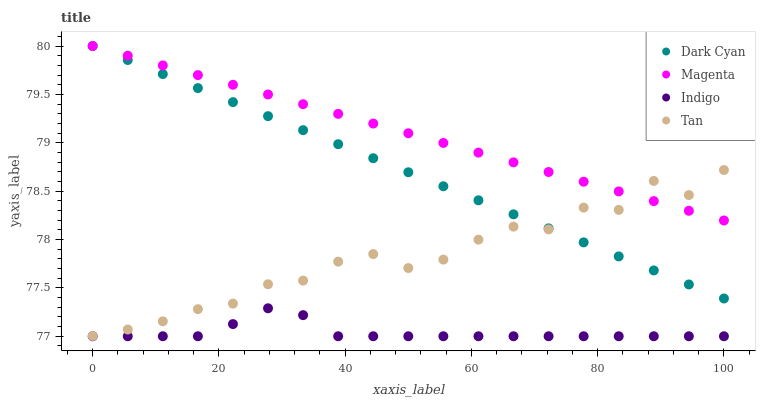Does Indigo have the minimum area under the curve?
Answer yes or no. Yes. Does Magenta have the maximum area under the curve?
Answer yes or no. Yes. Does Magenta have the minimum area under the curve?
Answer yes or no. No. Does Indigo have the maximum area under the curve?
Answer yes or no. No. Is Dark Cyan the smoothest?
Answer yes or no. Yes. Is Tan the roughest?
Answer yes or no. Yes. Is Magenta the smoothest?
Answer yes or no. No. Is Magenta the roughest?
Answer yes or no. No. Does Indigo have the lowest value?
Answer yes or no. Yes. Does Magenta have the lowest value?
Answer yes or no. No. Does Magenta have the highest value?
Answer yes or no. Yes. Does Indigo have the highest value?
Answer yes or no. No. Is Indigo less than Magenta?
Answer yes or no. Yes. Is Magenta greater than Indigo?
Answer yes or no. Yes. Does Tan intersect Magenta?
Answer yes or no. Yes. Is Tan less than Magenta?
Answer yes or no. No. Is Tan greater than Magenta?
Answer yes or no. No. Does Indigo intersect Magenta?
Answer yes or no. No. 